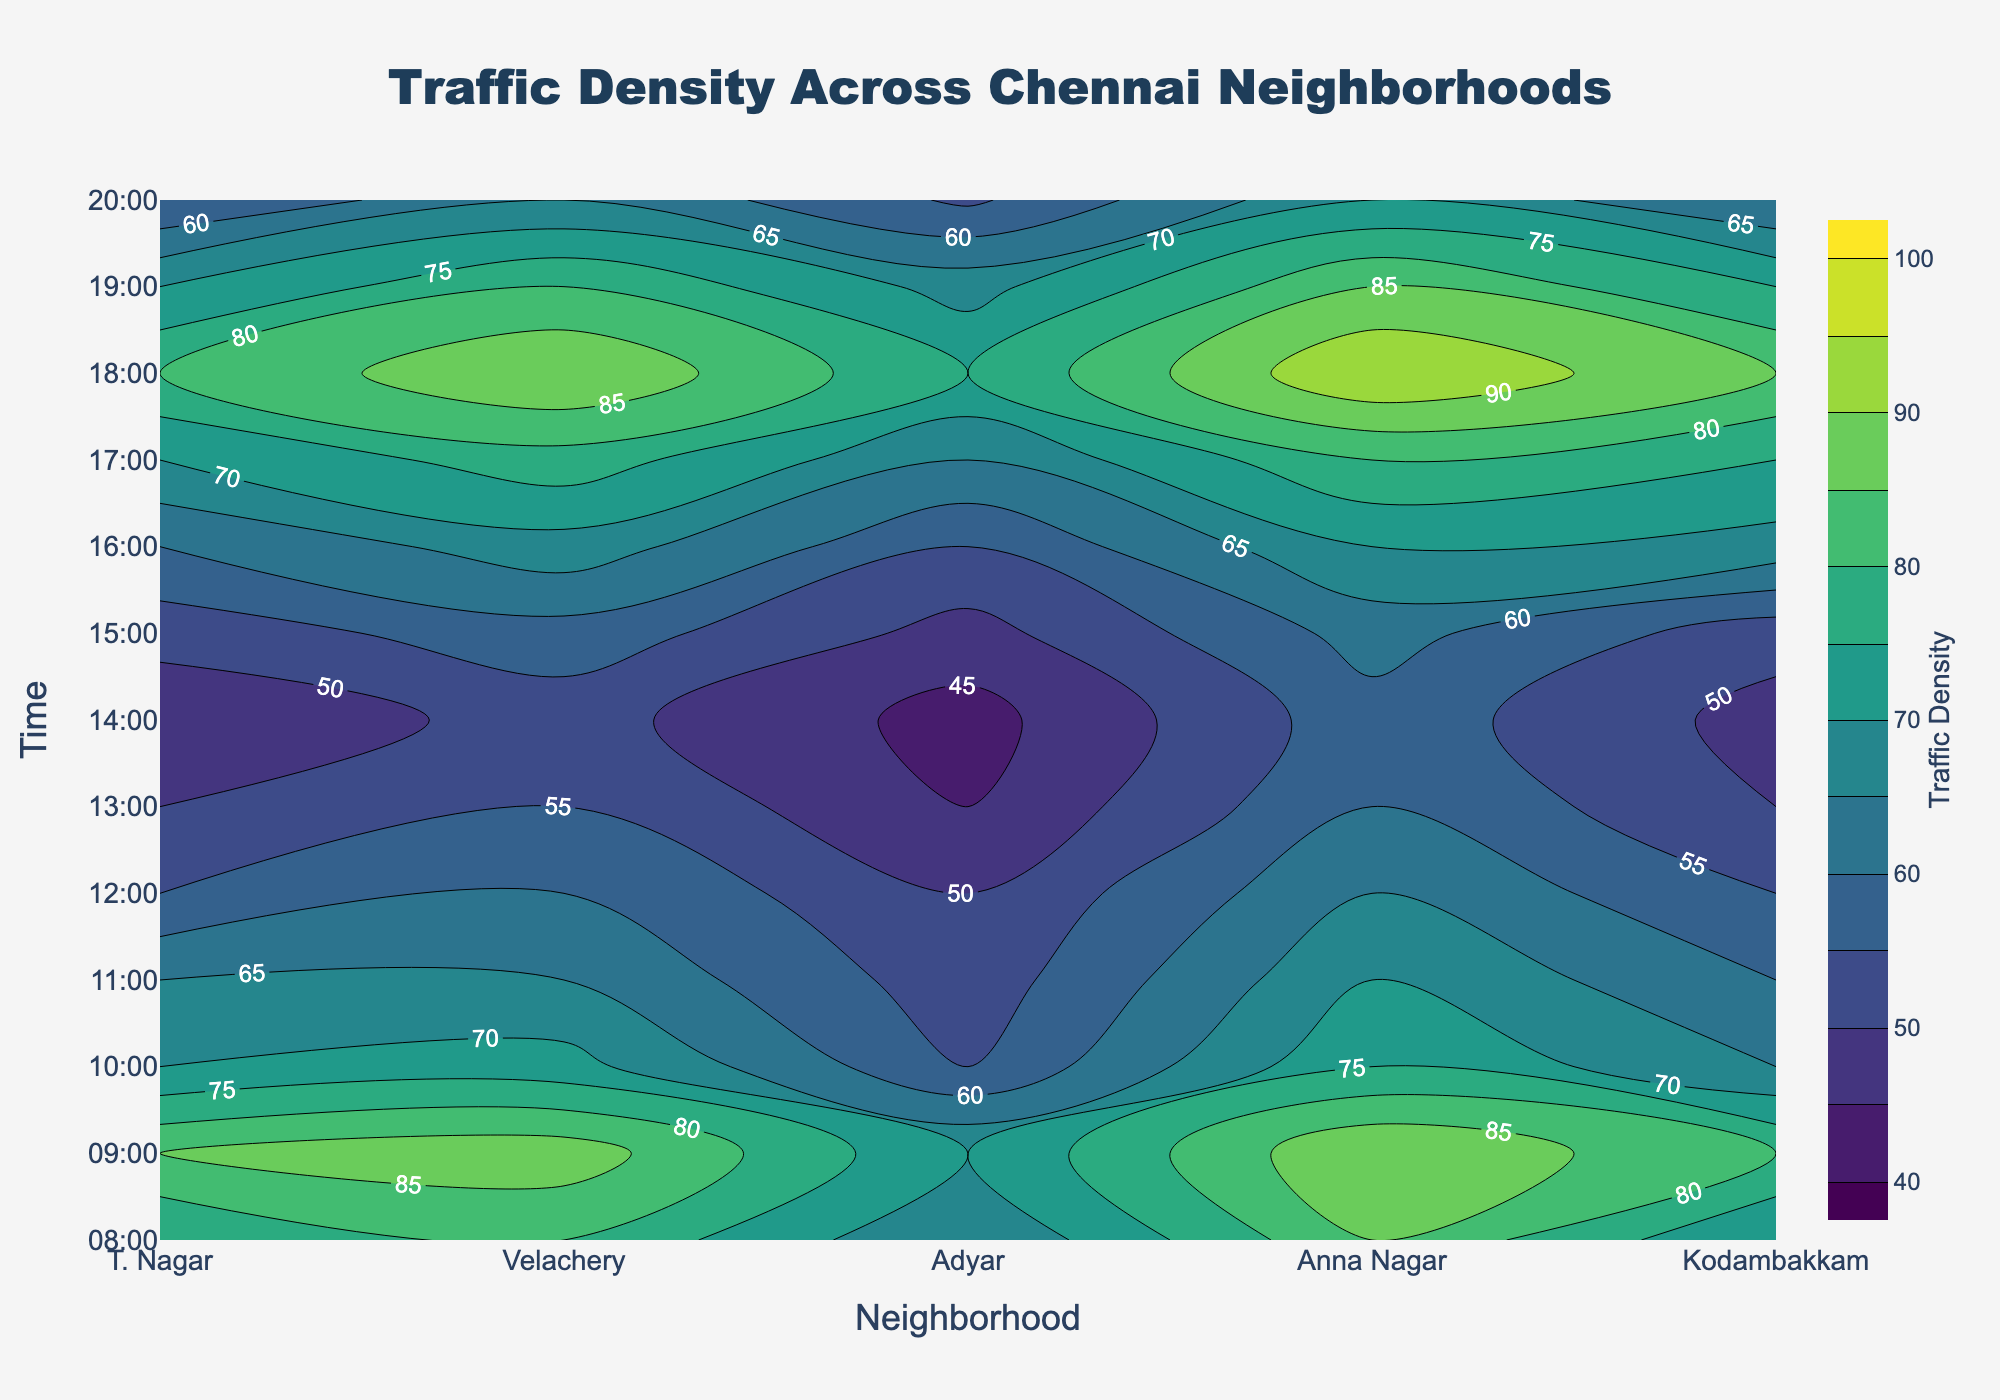What is the title of the plot? Look at the top of the figure to find the title. The title is centered and usually larger in font size to catch attention.
Answer: Traffic Density Across Chennai Neighborhoods Which neighborhood has the highest traffic density at 18:00? Examine the contour plot for the 18:00 time mark and look for the neighborhood with the darkest color, indicating the highest density.
Answer: T. Nagar At what time does Kodambakkam have the lowest traffic density? Identify the lightest color region corresponding to Kodambakkam along the Y-axis (time) and find the associated time.
Answer: 13:00 Which two neighborhoods show maximum traffic density at 09:00? Trace the 09:00 time mark on the Y-axis and check which two neighborhoods have the densest (darkest) color indicating maximum traffic density.
Answer: T. Nagar and Anna Nagar Compare the traffic density in T. Nagar and Velachery at 08:00. Which one is higher? Locate the 08:00 time mark for both T. Nagar and Velachery and compare the darkness of the corresponding contour colors. The darker color represents higher traffic density.
Answer: T. Nagar What is the average traffic density in Adyar from 17:00 to 19:00? Find the traffic density values for Adyar at 17:00, 18:00, and 19:00 and calculate their average: (70+80+70)/3.
Answer: 73.33 Which neighborhood experiences the most significant drop in traffic density from 09:00 to 11:00? Calculate the difference in traffic density values for each neighborhood between 09:00 and 11:00 and identify the largest decrease.
Answer: T. Nagar How does the traffic density in Anna Nagar change from 10:00 to 16:00? Observe the contour colors for Anna Nagar from 10:00 to 16:00. Note the traffic density variation, whether it increases or decreases during this period.
Answer: Decreases, then increases again At which time does T. Nagar experience a sudden peak in traffic density? Examine the contour plot for T. Nagar across different times and look for a sharp change in color indicating a peak.
Answer: 18:00 